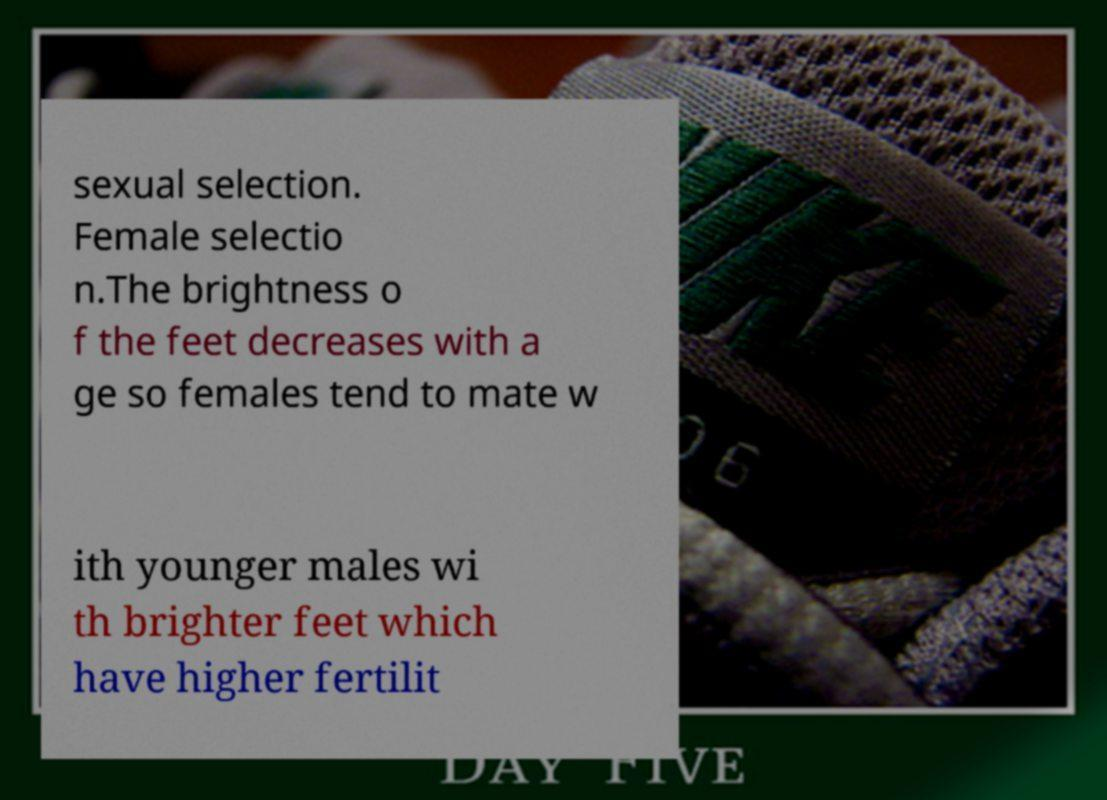Could you extract and type out the text from this image? sexual selection. Female selectio n.The brightness o f the feet decreases with a ge so females tend to mate w ith younger males wi th brighter feet which have higher fertilit 